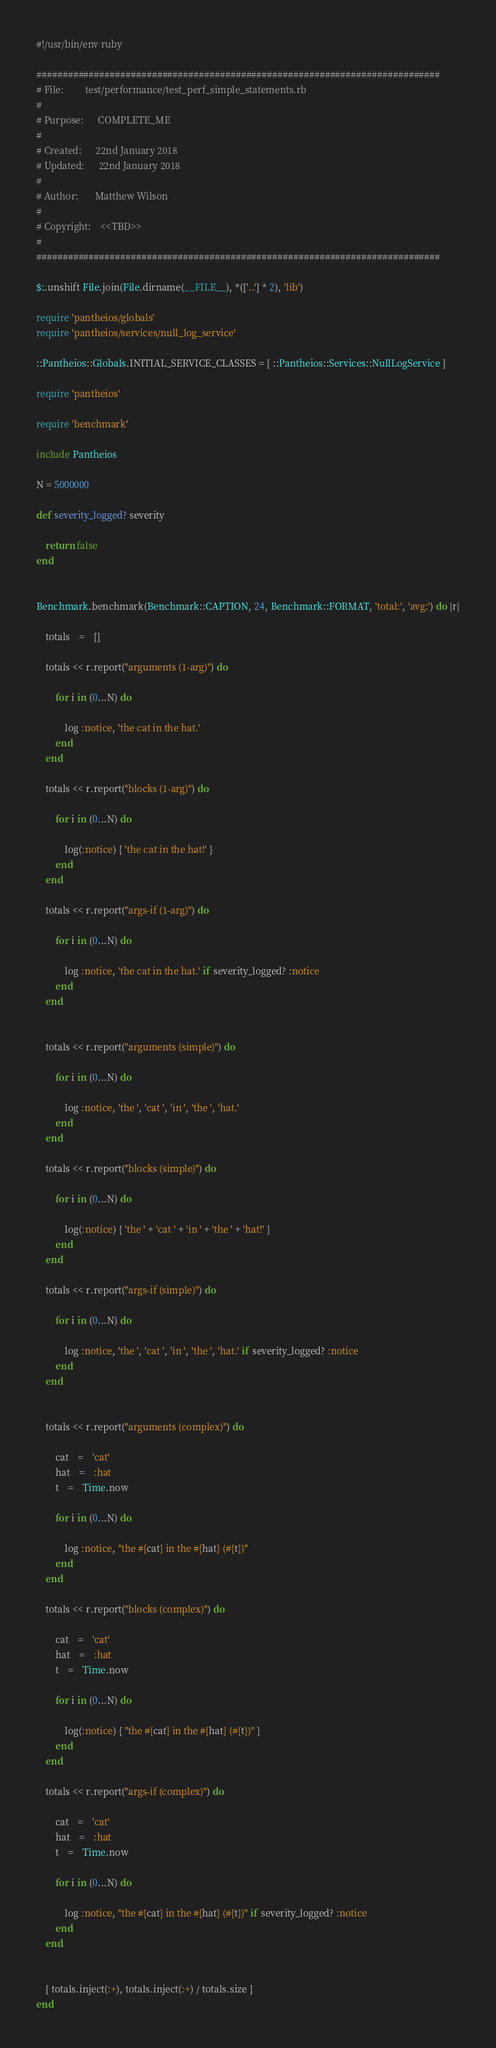Convert code to text. <code><loc_0><loc_0><loc_500><loc_500><_Ruby_>#!/usr/bin/env ruby

#############################################################################
# File:         test/performance/test_perf_simple_statements.rb
#
# Purpose:      COMPLETE_ME
#
# Created:      22nd January 2018
# Updated:      22nd January 2018
#
# Author:       Matthew Wilson
#
# Copyright:    <<TBD>>
#
#############################################################################

$:.unshift File.join(File.dirname(__FILE__), *(['..'] * 2), 'lib')

require 'pantheios/globals'
require 'pantheios/services/null_log_service'

::Pantheios::Globals.INITIAL_SERVICE_CLASSES = [ ::Pantheios::Services::NullLogService ]

require 'pantheios'

require 'benchmark'

include Pantheios

N = 5000000

def severity_logged? severity

	return false
end


Benchmark.benchmark(Benchmark::CAPTION, 24, Benchmark::FORMAT, 'total:', 'avg:') do |r|

	totals	=	[]

	totals << r.report("arguments (1-arg)") do

		for i in (0...N) do

			log :notice, 'the cat in the hat.'
		end
	end

	totals << r.report("blocks (1-arg)") do

		for i in (0...N) do

			log(:notice) { 'the cat in the hat!' }
		end
	end

	totals << r.report("args-if (1-arg)") do

		for i in (0...N) do

			log :notice, 'the cat in the hat.' if severity_logged? :notice
		end
	end


	totals << r.report("arguments (simple)") do

		for i in (0...N) do

			log :notice, 'the ', 'cat ', 'in ', 'the ', 'hat.'
		end
	end

	totals << r.report("blocks (simple)") do

		for i in (0...N) do

			log(:notice) { 'the ' + 'cat ' + 'in ' + 'the ' + 'hat!' }
		end
	end

	totals << r.report("args-if (simple)") do

		for i in (0...N) do

			log :notice, 'the ', 'cat ', 'in ', 'the ', 'hat.' if severity_logged? :notice
		end
	end


	totals << r.report("arguments (complex)") do

		cat	=	'cat'
		hat	=	:hat
		t	=	Time.now

		for i in (0...N) do

			log :notice, "the #{cat} in the #{hat} (#{t})"
		end
	end

	totals << r.report("blocks (complex)") do

		cat	=	'cat'
		hat	=	:hat
		t	=	Time.now

		for i in (0...N) do

			log(:notice) { "the #{cat} in the #{hat} (#{t})" }
		end
	end

	totals << r.report("args-if (complex)") do

		cat	=	'cat'
		hat	=	:hat
		t	=	Time.now

		for i in (0...N) do

			log :notice, "the #{cat} in the #{hat} (#{t})" if severity_logged? :notice
		end
	end


	[ totals.inject(:+), totals.inject(:+) / totals.size ]
end


</code> 